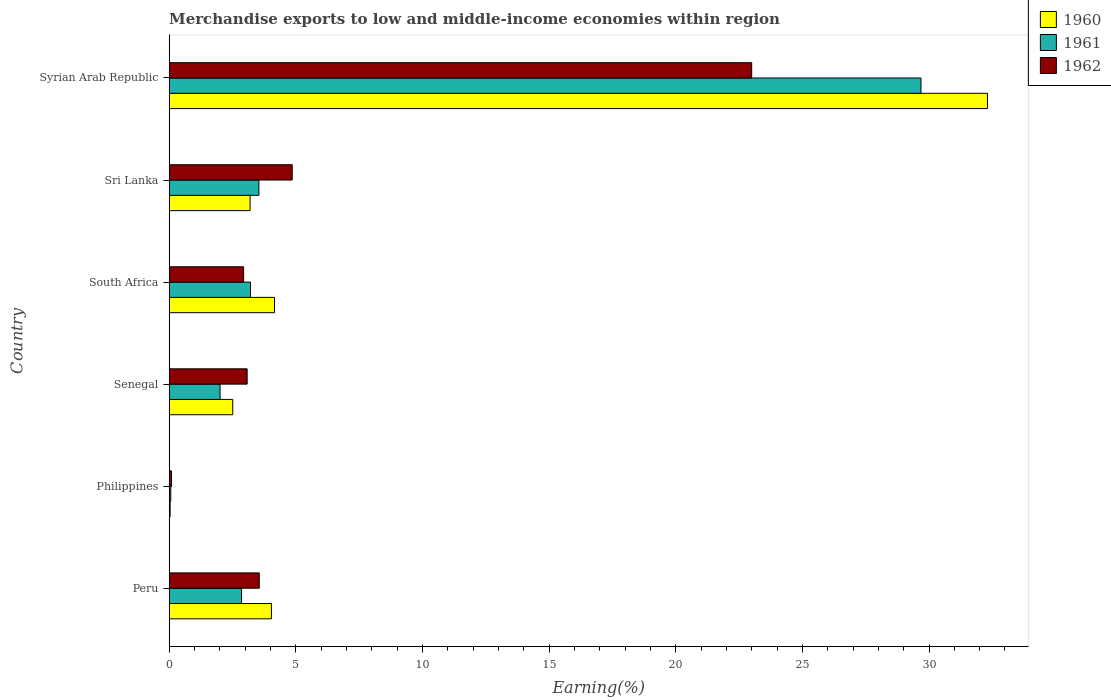How many different coloured bars are there?
Offer a very short reply. 3. Are the number of bars per tick equal to the number of legend labels?
Offer a very short reply. Yes. How many bars are there on the 3rd tick from the bottom?
Offer a very short reply. 3. What is the label of the 4th group of bars from the top?
Give a very brief answer. Senegal. What is the percentage of amount earned from merchandise exports in 1960 in Philippines?
Provide a succinct answer. 0.04. Across all countries, what is the maximum percentage of amount earned from merchandise exports in 1960?
Offer a terse response. 32.31. Across all countries, what is the minimum percentage of amount earned from merchandise exports in 1962?
Your answer should be compact. 0.09. In which country was the percentage of amount earned from merchandise exports in 1960 maximum?
Keep it short and to the point. Syrian Arab Republic. What is the total percentage of amount earned from merchandise exports in 1960 in the graph?
Give a very brief answer. 46.24. What is the difference between the percentage of amount earned from merchandise exports in 1960 in Senegal and that in South Africa?
Keep it short and to the point. -1.65. What is the difference between the percentage of amount earned from merchandise exports in 1960 in South Africa and the percentage of amount earned from merchandise exports in 1962 in Syrian Arab Republic?
Make the answer very short. -18.84. What is the average percentage of amount earned from merchandise exports in 1962 per country?
Offer a very short reply. 6.25. What is the difference between the percentage of amount earned from merchandise exports in 1960 and percentage of amount earned from merchandise exports in 1962 in Sri Lanka?
Give a very brief answer. -1.66. In how many countries, is the percentage of amount earned from merchandise exports in 1962 greater than 19 %?
Provide a short and direct response. 1. What is the ratio of the percentage of amount earned from merchandise exports in 1961 in Peru to that in Philippines?
Give a very brief answer. 46.4. What is the difference between the highest and the second highest percentage of amount earned from merchandise exports in 1960?
Your answer should be compact. 28.15. What is the difference between the highest and the lowest percentage of amount earned from merchandise exports in 1960?
Offer a terse response. 32.27. In how many countries, is the percentage of amount earned from merchandise exports in 1960 greater than the average percentage of amount earned from merchandise exports in 1960 taken over all countries?
Your answer should be compact. 1. What does the 2nd bar from the bottom in Senegal represents?
Your answer should be very brief. 1961. How many bars are there?
Provide a succinct answer. 18. Are all the bars in the graph horizontal?
Your response must be concise. Yes. How many countries are there in the graph?
Your response must be concise. 6. What is the difference between two consecutive major ticks on the X-axis?
Your response must be concise. 5. Does the graph contain any zero values?
Provide a succinct answer. No. Does the graph contain grids?
Offer a very short reply. No. Where does the legend appear in the graph?
Provide a succinct answer. Top right. How many legend labels are there?
Your answer should be compact. 3. What is the title of the graph?
Ensure brevity in your answer.  Merchandise exports to low and middle-income economies within region. Does "1967" appear as one of the legend labels in the graph?
Your response must be concise. No. What is the label or title of the X-axis?
Keep it short and to the point. Earning(%). What is the label or title of the Y-axis?
Offer a very short reply. Country. What is the Earning(%) in 1960 in Peru?
Provide a short and direct response. 4.04. What is the Earning(%) of 1961 in Peru?
Provide a short and direct response. 2.86. What is the Earning(%) of 1962 in Peru?
Give a very brief answer. 3.56. What is the Earning(%) of 1960 in Philippines?
Keep it short and to the point. 0.04. What is the Earning(%) of 1961 in Philippines?
Give a very brief answer. 0.06. What is the Earning(%) in 1962 in Philippines?
Make the answer very short. 0.09. What is the Earning(%) in 1960 in Senegal?
Offer a very short reply. 2.51. What is the Earning(%) in 1961 in Senegal?
Offer a very short reply. 2.01. What is the Earning(%) of 1962 in Senegal?
Provide a short and direct response. 3.08. What is the Earning(%) of 1960 in South Africa?
Offer a very short reply. 4.16. What is the Earning(%) in 1961 in South Africa?
Keep it short and to the point. 3.21. What is the Earning(%) of 1962 in South Africa?
Your answer should be very brief. 2.94. What is the Earning(%) of 1960 in Sri Lanka?
Your answer should be very brief. 3.19. What is the Earning(%) in 1961 in Sri Lanka?
Keep it short and to the point. 3.54. What is the Earning(%) in 1962 in Sri Lanka?
Your response must be concise. 4.86. What is the Earning(%) in 1960 in Syrian Arab Republic?
Your response must be concise. 32.31. What is the Earning(%) in 1961 in Syrian Arab Republic?
Give a very brief answer. 29.68. What is the Earning(%) of 1962 in Syrian Arab Republic?
Give a very brief answer. 23. Across all countries, what is the maximum Earning(%) of 1960?
Your answer should be compact. 32.31. Across all countries, what is the maximum Earning(%) in 1961?
Keep it short and to the point. 29.68. Across all countries, what is the maximum Earning(%) in 1962?
Your response must be concise. 23. Across all countries, what is the minimum Earning(%) in 1960?
Offer a very short reply. 0.04. Across all countries, what is the minimum Earning(%) in 1961?
Offer a very short reply. 0.06. Across all countries, what is the minimum Earning(%) in 1962?
Give a very brief answer. 0.09. What is the total Earning(%) in 1960 in the graph?
Offer a terse response. 46.24. What is the total Earning(%) of 1961 in the graph?
Make the answer very short. 41.36. What is the total Earning(%) of 1962 in the graph?
Provide a short and direct response. 37.52. What is the difference between the Earning(%) of 1960 in Peru and that in Philippines?
Provide a short and direct response. 4. What is the difference between the Earning(%) in 1961 in Peru and that in Philippines?
Provide a succinct answer. 2.79. What is the difference between the Earning(%) of 1962 in Peru and that in Philippines?
Provide a succinct answer. 3.47. What is the difference between the Earning(%) in 1960 in Peru and that in Senegal?
Offer a very short reply. 1.53. What is the difference between the Earning(%) of 1961 in Peru and that in Senegal?
Provide a succinct answer. 0.85. What is the difference between the Earning(%) in 1962 in Peru and that in Senegal?
Give a very brief answer. 0.48. What is the difference between the Earning(%) of 1960 in Peru and that in South Africa?
Your response must be concise. -0.12. What is the difference between the Earning(%) of 1961 in Peru and that in South Africa?
Ensure brevity in your answer.  -0.35. What is the difference between the Earning(%) in 1962 in Peru and that in South Africa?
Your answer should be compact. 0.62. What is the difference between the Earning(%) in 1960 in Peru and that in Sri Lanka?
Your response must be concise. 0.84. What is the difference between the Earning(%) in 1961 in Peru and that in Sri Lanka?
Your response must be concise. -0.69. What is the difference between the Earning(%) of 1962 in Peru and that in Sri Lanka?
Make the answer very short. -1.3. What is the difference between the Earning(%) in 1960 in Peru and that in Syrian Arab Republic?
Your response must be concise. -28.27. What is the difference between the Earning(%) in 1961 in Peru and that in Syrian Arab Republic?
Your response must be concise. -26.83. What is the difference between the Earning(%) of 1962 in Peru and that in Syrian Arab Republic?
Offer a very short reply. -19.44. What is the difference between the Earning(%) in 1960 in Philippines and that in Senegal?
Ensure brevity in your answer.  -2.47. What is the difference between the Earning(%) of 1961 in Philippines and that in Senegal?
Make the answer very short. -1.95. What is the difference between the Earning(%) of 1962 in Philippines and that in Senegal?
Give a very brief answer. -2.99. What is the difference between the Earning(%) in 1960 in Philippines and that in South Africa?
Make the answer very short. -4.12. What is the difference between the Earning(%) in 1961 in Philippines and that in South Africa?
Offer a terse response. -3.15. What is the difference between the Earning(%) in 1962 in Philippines and that in South Africa?
Your answer should be very brief. -2.85. What is the difference between the Earning(%) of 1960 in Philippines and that in Sri Lanka?
Ensure brevity in your answer.  -3.16. What is the difference between the Earning(%) in 1961 in Philippines and that in Sri Lanka?
Keep it short and to the point. -3.48. What is the difference between the Earning(%) in 1962 in Philippines and that in Sri Lanka?
Provide a succinct answer. -4.77. What is the difference between the Earning(%) of 1960 in Philippines and that in Syrian Arab Republic?
Provide a succinct answer. -32.27. What is the difference between the Earning(%) in 1961 in Philippines and that in Syrian Arab Republic?
Provide a short and direct response. -29.62. What is the difference between the Earning(%) in 1962 in Philippines and that in Syrian Arab Republic?
Keep it short and to the point. -22.91. What is the difference between the Earning(%) of 1960 in Senegal and that in South Africa?
Offer a terse response. -1.65. What is the difference between the Earning(%) in 1961 in Senegal and that in South Africa?
Provide a short and direct response. -1.2. What is the difference between the Earning(%) of 1962 in Senegal and that in South Africa?
Offer a very short reply. 0.14. What is the difference between the Earning(%) of 1960 in Senegal and that in Sri Lanka?
Provide a succinct answer. -0.68. What is the difference between the Earning(%) in 1961 in Senegal and that in Sri Lanka?
Your response must be concise. -1.53. What is the difference between the Earning(%) of 1962 in Senegal and that in Sri Lanka?
Your answer should be compact. -1.78. What is the difference between the Earning(%) of 1960 in Senegal and that in Syrian Arab Republic?
Give a very brief answer. -29.8. What is the difference between the Earning(%) in 1961 in Senegal and that in Syrian Arab Republic?
Your answer should be compact. -27.68. What is the difference between the Earning(%) of 1962 in Senegal and that in Syrian Arab Republic?
Offer a terse response. -19.92. What is the difference between the Earning(%) of 1960 in South Africa and that in Sri Lanka?
Give a very brief answer. 0.96. What is the difference between the Earning(%) in 1961 in South Africa and that in Sri Lanka?
Provide a short and direct response. -0.33. What is the difference between the Earning(%) of 1962 in South Africa and that in Sri Lanka?
Your response must be concise. -1.92. What is the difference between the Earning(%) of 1960 in South Africa and that in Syrian Arab Republic?
Ensure brevity in your answer.  -28.15. What is the difference between the Earning(%) of 1961 in South Africa and that in Syrian Arab Republic?
Keep it short and to the point. -26.47. What is the difference between the Earning(%) of 1962 in South Africa and that in Syrian Arab Republic?
Provide a short and direct response. -20.06. What is the difference between the Earning(%) of 1960 in Sri Lanka and that in Syrian Arab Republic?
Offer a very short reply. -29.11. What is the difference between the Earning(%) in 1961 in Sri Lanka and that in Syrian Arab Republic?
Ensure brevity in your answer.  -26.14. What is the difference between the Earning(%) of 1962 in Sri Lanka and that in Syrian Arab Republic?
Your answer should be very brief. -18.14. What is the difference between the Earning(%) of 1960 in Peru and the Earning(%) of 1961 in Philippines?
Make the answer very short. 3.97. What is the difference between the Earning(%) in 1960 in Peru and the Earning(%) in 1962 in Philippines?
Offer a very short reply. 3.95. What is the difference between the Earning(%) of 1961 in Peru and the Earning(%) of 1962 in Philippines?
Keep it short and to the point. 2.77. What is the difference between the Earning(%) of 1960 in Peru and the Earning(%) of 1961 in Senegal?
Provide a succinct answer. 2.03. What is the difference between the Earning(%) in 1960 in Peru and the Earning(%) in 1962 in Senegal?
Give a very brief answer. 0.96. What is the difference between the Earning(%) of 1961 in Peru and the Earning(%) of 1962 in Senegal?
Keep it short and to the point. -0.22. What is the difference between the Earning(%) in 1960 in Peru and the Earning(%) in 1961 in South Africa?
Ensure brevity in your answer.  0.83. What is the difference between the Earning(%) of 1960 in Peru and the Earning(%) of 1962 in South Africa?
Offer a very short reply. 1.1. What is the difference between the Earning(%) of 1961 in Peru and the Earning(%) of 1962 in South Africa?
Your answer should be very brief. -0.08. What is the difference between the Earning(%) in 1960 in Peru and the Earning(%) in 1961 in Sri Lanka?
Your answer should be compact. 0.5. What is the difference between the Earning(%) of 1960 in Peru and the Earning(%) of 1962 in Sri Lanka?
Your answer should be very brief. -0.82. What is the difference between the Earning(%) in 1961 in Peru and the Earning(%) in 1962 in Sri Lanka?
Your answer should be compact. -2. What is the difference between the Earning(%) in 1960 in Peru and the Earning(%) in 1961 in Syrian Arab Republic?
Your response must be concise. -25.65. What is the difference between the Earning(%) of 1960 in Peru and the Earning(%) of 1962 in Syrian Arab Republic?
Provide a succinct answer. -18.96. What is the difference between the Earning(%) in 1961 in Peru and the Earning(%) in 1962 in Syrian Arab Republic?
Your response must be concise. -20.14. What is the difference between the Earning(%) in 1960 in Philippines and the Earning(%) in 1961 in Senegal?
Provide a succinct answer. -1.97. What is the difference between the Earning(%) of 1960 in Philippines and the Earning(%) of 1962 in Senegal?
Give a very brief answer. -3.04. What is the difference between the Earning(%) of 1961 in Philippines and the Earning(%) of 1962 in Senegal?
Offer a very short reply. -3.02. What is the difference between the Earning(%) of 1960 in Philippines and the Earning(%) of 1961 in South Africa?
Your answer should be very brief. -3.17. What is the difference between the Earning(%) in 1960 in Philippines and the Earning(%) in 1962 in South Africa?
Give a very brief answer. -2.9. What is the difference between the Earning(%) in 1961 in Philippines and the Earning(%) in 1962 in South Africa?
Keep it short and to the point. -2.88. What is the difference between the Earning(%) in 1960 in Philippines and the Earning(%) in 1961 in Sri Lanka?
Make the answer very short. -3.5. What is the difference between the Earning(%) in 1960 in Philippines and the Earning(%) in 1962 in Sri Lanka?
Provide a short and direct response. -4.82. What is the difference between the Earning(%) of 1961 in Philippines and the Earning(%) of 1962 in Sri Lanka?
Keep it short and to the point. -4.8. What is the difference between the Earning(%) in 1960 in Philippines and the Earning(%) in 1961 in Syrian Arab Republic?
Your response must be concise. -29.65. What is the difference between the Earning(%) of 1960 in Philippines and the Earning(%) of 1962 in Syrian Arab Republic?
Ensure brevity in your answer.  -22.96. What is the difference between the Earning(%) of 1961 in Philippines and the Earning(%) of 1962 in Syrian Arab Republic?
Your response must be concise. -22.94. What is the difference between the Earning(%) of 1960 in Senegal and the Earning(%) of 1961 in South Africa?
Give a very brief answer. -0.7. What is the difference between the Earning(%) of 1960 in Senegal and the Earning(%) of 1962 in South Africa?
Offer a very short reply. -0.43. What is the difference between the Earning(%) of 1961 in Senegal and the Earning(%) of 1962 in South Africa?
Provide a succinct answer. -0.93. What is the difference between the Earning(%) in 1960 in Senegal and the Earning(%) in 1961 in Sri Lanka?
Ensure brevity in your answer.  -1.03. What is the difference between the Earning(%) in 1960 in Senegal and the Earning(%) in 1962 in Sri Lanka?
Your answer should be very brief. -2.35. What is the difference between the Earning(%) of 1961 in Senegal and the Earning(%) of 1962 in Sri Lanka?
Your answer should be very brief. -2.85. What is the difference between the Earning(%) in 1960 in Senegal and the Earning(%) in 1961 in Syrian Arab Republic?
Your answer should be compact. -27.17. What is the difference between the Earning(%) of 1960 in Senegal and the Earning(%) of 1962 in Syrian Arab Republic?
Give a very brief answer. -20.49. What is the difference between the Earning(%) in 1961 in Senegal and the Earning(%) in 1962 in Syrian Arab Republic?
Offer a very short reply. -20.99. What is the difference between the Earning(%) of 1960 in South Africa and the Earning(%) of 1961 in Sri Lanka?
Offer a very short reply. 0.62. What is the difference between the Earning(%) of 1960 in South Africa and the Earning(%) of 1962 in Sri Lanka?
Your response must be concise. -0.7. What is the difference between the Earning(%) of 1961 in South Africa and the Earning(%) of 1962 in Sri Lanka?
Keep it short and to the point. -1.65. What is the difference between the Earning(%) in 1960 in South Africa and the Earning(%) in 1961 in Syrian Arab Republic?
Your answer should be very brief. -25.53. What is the difference between the Earning(%) in 1960 in South Africa and the Earning(%) in 1962 in Syrian Arab Republic?
Offer a terse response. -18.84. What is the difference between the Earning(%) of 1961 in South Africa and the Earning(%) of 1962 in Syrian Arab Republic?
Your response must be concise. -19.79. What is the difference between the Earning(%) of 1960 in Sri Lanka and the Earning(%) of 1961 in Syrian Arab Republic?
Your response must be concise. -26.49. What is the difference between the Earning(%) of 1960 in Sri Lanka and the Earning(%) of 1962 in Syrian Arab Republic?
Ensure brevity in your answer.  -19.8. What is the difference between the Earning(%) of 1961 in Sri Lanka and the Earning(%) of 1962 in Syrian Arab Republic?
Provide a short and direct response. -19.46. What is the average Earning(%) in 1960 per country?
Your answer should be compact. 7.71. What is the average Earning(%) of 1961 per country?
Make the answer very short. 6.89. What is the average Earning(%) of 1962 per country?
Your answer should be compact. 6.25. What is the difference between the Earning(%) in 1960 and Earning(%) in 1961 in Peru?
Give a very brief answer. 1.18. What is the difference between the Earning(%) of 1960 and Earning(%) of 1962 in Peru?
Your answer should be compact. 0.48. What is the difference between the Earning(%) of 1961 and Earning(%) of 1962 in Peru?
Your response must be concise. -0.7. What is the difference between the Earning(%) of 1960 and Earning(%) of 1961 in Philippines?
Provide a short and direct response. -0.02. What is the difference between the Earning(%) of 1960 and Earning(%) of 1962 in Philippines?
Make the answer very short. -0.05. What is the difference between the Earning(%) of 1961 and Earning(%) of 1962 in Philippines?
Offer a terse response. -0.03. What is the difference between the Earning(%) of 1960 and Earning(%) of 1961 in Senegal?
Make the answer very short. 0.5. What is the difference between the Earning(%) of 1960 and Earning(%) of 1962 in Senegal?
Ensure brevity in your answer.  -0.57. What is the difference between the Earning(%) of 1961 and Earning(%) of 1962 in Senegal?
Offer a very short reply. -1.07. What is the difference between the Earning(%) in 1960 and Earning(%) in 1961 in South Africa?
Give a very brief answer. 0.95. What is the difference between the Earning(%) in 1960 and Earning(%) in 1962 in South Africa?
Your response must be concise. 1.22. What is the difference between the Earning(%) of 1961 and Earning(%) of 1962 in South Africa?
Offer a terse response. 0.27. What is the difference between the Earning(%) in 1960 and Earning(%) in 1961 in Sri Lanka?
Provide a short and direct response. -0.35. What is the difference between the Earning(%) of 1960 and Earning(%) of 1962 in Sri Lanka?
Your answer should be very brief. -1.66. What is the difference between the Earning(%) of 1961 and Earning(%) of 1962 in Sri Lanka?
Your response must be concise. -1.32. What is the difference between the Earning(%) in 1960 and Earning(%) in 1961 in Syrian Arab Republic?
Your response must be concise. 2.62. What is the difference between the Earning(%) in 1960 and Earning(%) in 1962 in Syrian Arab Republic?
Offer a very short reply. 9.31. What is the difference between the Earning(%) in 1961 and Earning(%) in 1962 in Syrian Arab Republic?
Offer a terse response. 6.68. What is the ratio of the Earning(%) in 1960 in Peru to that in Philippines?
Your answer should be very brief. 108.37. What is the ratio of the Earning(%) in 1961 in Peru to that in Philippines?
Ensure brevity in your answer.  46.4. What is the ratio of the Earning(%) in 1962 in Peru to that in Philippines?
Provide a succinct answer. 39.35. What is the ratio of the Earning(%) of 1960 in Peru to that in Senegal?
Ensure brevity in your answer.  1.61. What is the ratio of the Earning(%) in 1961 in Peru to that in Senegal?
Keep it short and to the point. 1.42. What is the ratio of the Earning(%) of 1962 in Peru to that in Senegal?
Offer a very short reply. 1.16. What is the ratio of the Earning(%) in 1960 in Peru to that in South Africa?
Offer a very short reply. 0.97. What is the ratio of the Earning(%) of 1961 in Peru to that in South Africa?
Ensure brevity in your answer.  0.89. What is the ratio of the Earning(%) of 1962 in Peru to that in South Africa?
Offer a very short reply. 1.21. What is the ratio of the Earning(%) of 1960 in Peru to that in Sri Lanka?
Your response must be concise. 1.26. What is the ratio of the Earning(%) of 1961 in Peru to that in Sri Lanka?
Keep it short and to the point. 0.81. What is the ratio of the Earning(%) in 1962 in Peru to that in Sri Lanka?
Keep it short and to the point. 0.73. What is the ratio of the Earning(%) of 1960 in Peru to that in Syrian Arab Republic?
Offer a very short reply. 0.12. What is the ratio of the Earning(%) in 1961 in Peru to that in Syrian Arab Republic?
Ensure brevity in your answer.  0.1. What is the ratio of the Earning(%) in 1962 in Peru to that in Syrian Arab Republic?
Keep it short and to the point. 0.15. What is the ratio of the Earning(%) of 1960 in Philippines to that in Senegal?
Your answer should be very brief. 0.01. What is the ratio of the Earning(%) in 1961 in Philippines to that in Senegal?
Offer a very short reply. 0.03. What is the ratio of the Earning(%) in 1962 in Philippines to that in Senegal?
Your answer should be very brief. 0.03. What is the ratio of the Earning(%) of 1960 in Philippines to that in South Africa?
Keep it short and to the point. 0.01. What is the ratio of the Earning(%) of 1961 in Philippines to that in South Africa?
Offer a terse response. 0.02. What is the ratio of the Earning(%) of 1962 in Philippines to that in South Africa?
Your answer should be compact. 0.03. What is the ratio of the Earning(%) in 1960 in Philippines to that in Sri Lanka?
Your answer should be very brief. 0.01. What is the ratio of the Earning(%) in 1961 in Philippines to that in Sri Lanka?
Give a very brief answer. 0.02. What is the ratio of the Earning(%) in 1962 in Philippines to that in Sri Lanka?
Keep it short and to the point. 0.02. What is the ratio of the Earning(%) of 1960 in Philippines to that in Syrian Arab Republic?
Provide a succinct answer. 0. What is the ratio of the Earning(%) of 1961 in Philippines to that in Syrian Arab Republic?
Give a very brief answer. 0. What is the ratio of the Earning(%) in 1962 in Philippines to that in Syrian Arab Republic?
Provide a short and direct response. 0. What is the ratio of the Earning(%) of 1960 in Senegal to that in South Africa?
Provide a short and direct response. 0.6. What is the ratio of the Earning(%) of 1961 in Senegal to that in South Africa?
Your answer should be very brief. 0.63. What is the ratio of the Earning(%) in 1962 in Senegal to that in South Africa?
Your response must be concise. 1.05. What is the ratio of the Earning(%) of 1960 in Senegal to that in Sri Lanka?
Provide a short and direct response. 0.79. What is the ratio of the Earning(%) of 1961 in Senegal to that in Sri Lanka?
Provide a succinct answer. 0.57. What is the ratio of the Earning(%) in 1962 in Senegal to that in Sri Lanka?
Make the answer very short. 0.63. What is the ratio of the Earning(%) of 1960 in Senegal to that in Syrian Arab Republic?
Make the answer very short. 0.08. What is the ratio of the Earning(%) in 1961 in Senegal to that in Syrian Arab Republic?
Your answer should be compact. 0.07. What is the ratio of the Earning(%) in 1962 in Senegal to that in Syrian Arab Republic?
Offer a terse response. 0.13. What is the ratio of the Earning(%) in 1960 in South Africa to that in Sri Lanka?
Offer a terse response. 1.3. What is the ratio of the Earning(%) in 1961 in South Africa to that in Sri Lanka?
Give a very brief answer. 0.91. What is the ratio of the Earning(%) of 1962 in South Africa to that in Sri Lanka?
Give a very brief answer. 0.6. What is the ratio of the Earning(%) in 1960 in South Africa to that in Syrian Arab Republic?
Provide a succinct answer. 0.13. What is the ratio of the Earning(%) in 1961 in South Africa to that in Syrian Arab Republic?
Your answer should be compact. 0.11. What is the ratio of the Earning(%) in 1962 in South Africa to that in Syrian Arab Republic?
Offer a very short reply. 0.13. What is the ratio of the Earning(%) of 1960 in Sri Lanka to that in Syrian Arab Republic?
Offer a very short reply. 0.1. What is the ratio of the Earning(%) in 1961 in Sri Lanka to that in Syrian Arab Republic?
Make the answer very short. 0.12. What is the ratio of the Earning(%) of 1962 in Sri Lanka to that in Syrian Arab Republic?
Make the answer very short. 0.21. What is the difference between the highest and the second highest Earning(%) of 1960?
Give a very brief answer. 28.15. What is the difference between the highest and the second highest Earning(%) in 1961?
Offer a terse response. 26.14. What is the difference between the highest and the second highest Earning(%) of 1962?
Offer a very short reply. 18.14. What is the difference between the highest and the lowest Earning(%) of 1960?
Provide a succinct answer. 32.27. What is the difference between the highest and the lowest Earning(%) in 1961?
Your answer should be compact. 29.62. What is the difference between the highest and the lowest Earning(%) in 1962?
Make the answer very short. 22.91. 